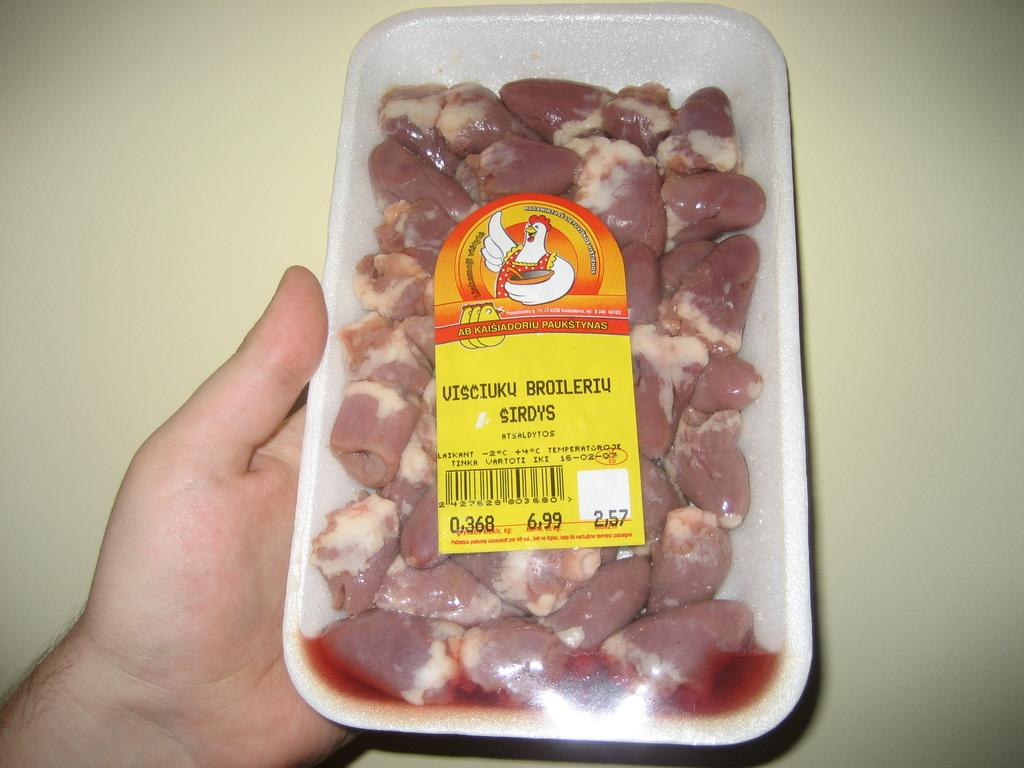What is the person in the image holding? The person is holding a box in the image. What is inside the box? The box contains meat. How can the contents of the box be identified? The box has a sticker on it. What can be seen in the background of the image? There is a wall in the background of the image. Can you see the person's mouth in the image? The image does not show the person's mouth; it only shows the person holding a box. Is there a goose present in the image? There is no goose visible in the image. 